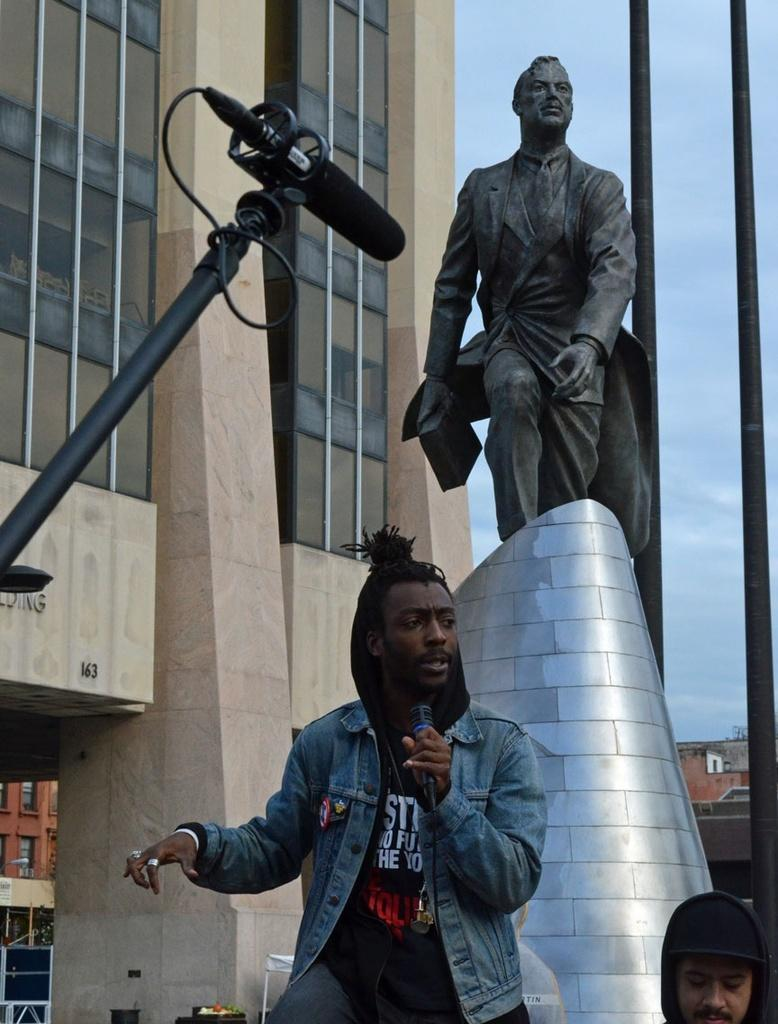What is the main subject in the image? There is a statue in the image. What is happening in the foreground of the image? There is a person holding a microphone in the foreground of the image. Can you describe the microphone placement in the image? There is a microphone at the top of the image. What type of worm can be seen crawling on the statue in the image? There is no worm present in the image; the statue is the main subject. 